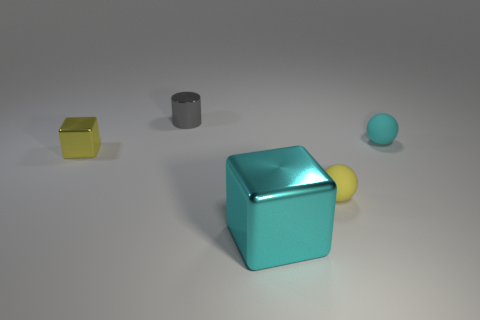Add 2 big cyan blocks. How many objects exist? 7 Subtract all cylinders. How many objects are left? 4 Subtract all small cylinders. Subtract all small cyan balls. How many objects are left? 3 Add 2 small cyan matte objects. How many small cyan matte objects are left? 3 Add 1 small yellow metallic objects. How many small yellow metallic objects exist? 2 Subtract 0 blue cubes. How many objects are left? 5 